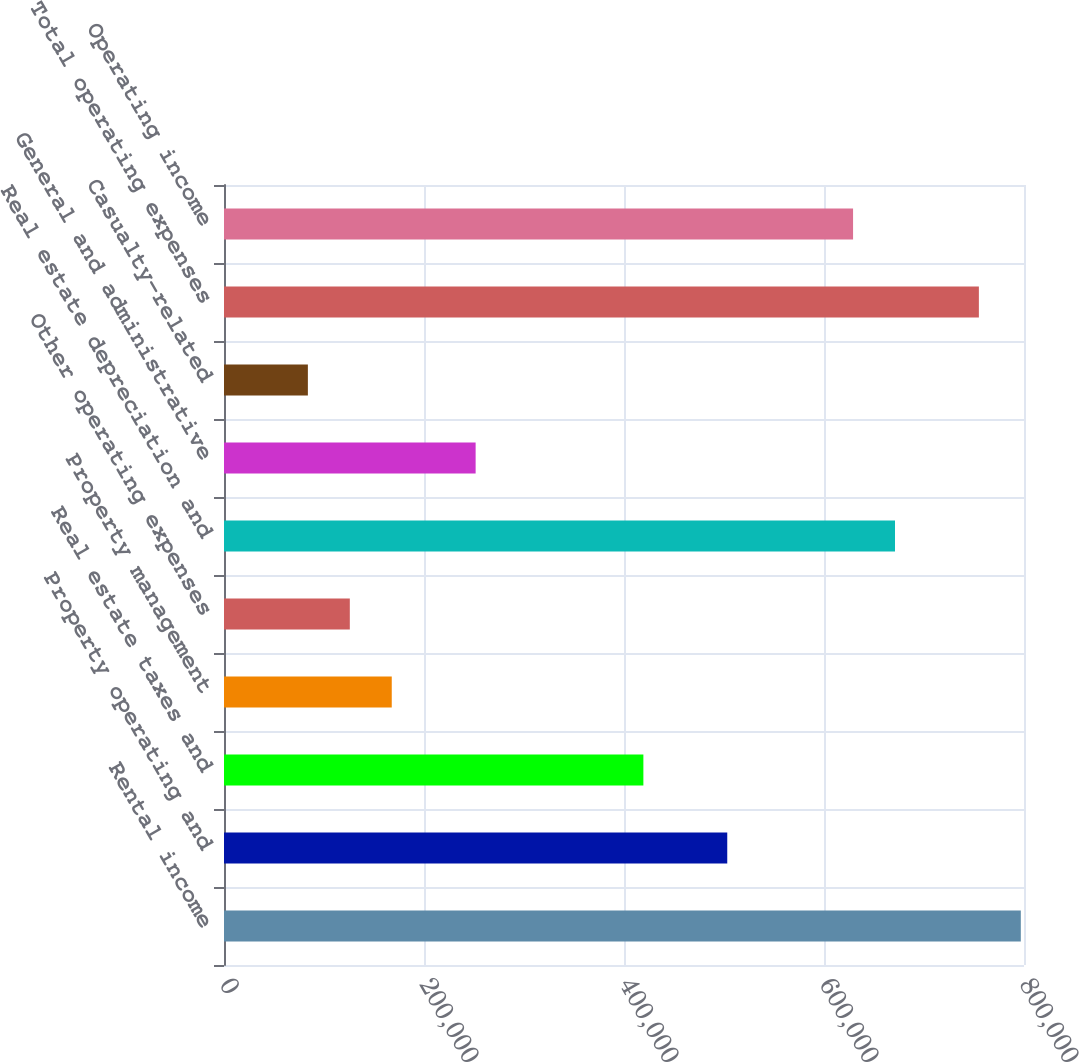Convert chart. <chart><loc_0><loc_0><loc_500><loc_500><bar_chart><fcel>Rental income<fcel>Property operating and<fcel>Real estate taxes and<fcel>Property management<fcel>Other operating expenses<fcel>Real estate depreciation and<fcel>General and administrative<fcel>Casualty-related<fcel>Total operating expenses<fcel>Operating income<nl><fcel>796816<fcel>503252<fcel>419377<fcel>167751<fcel>125814<fcel>671003<fcel>251626<fcel>83875.9<fcel>754878<fcel>629065<nl></chart> 